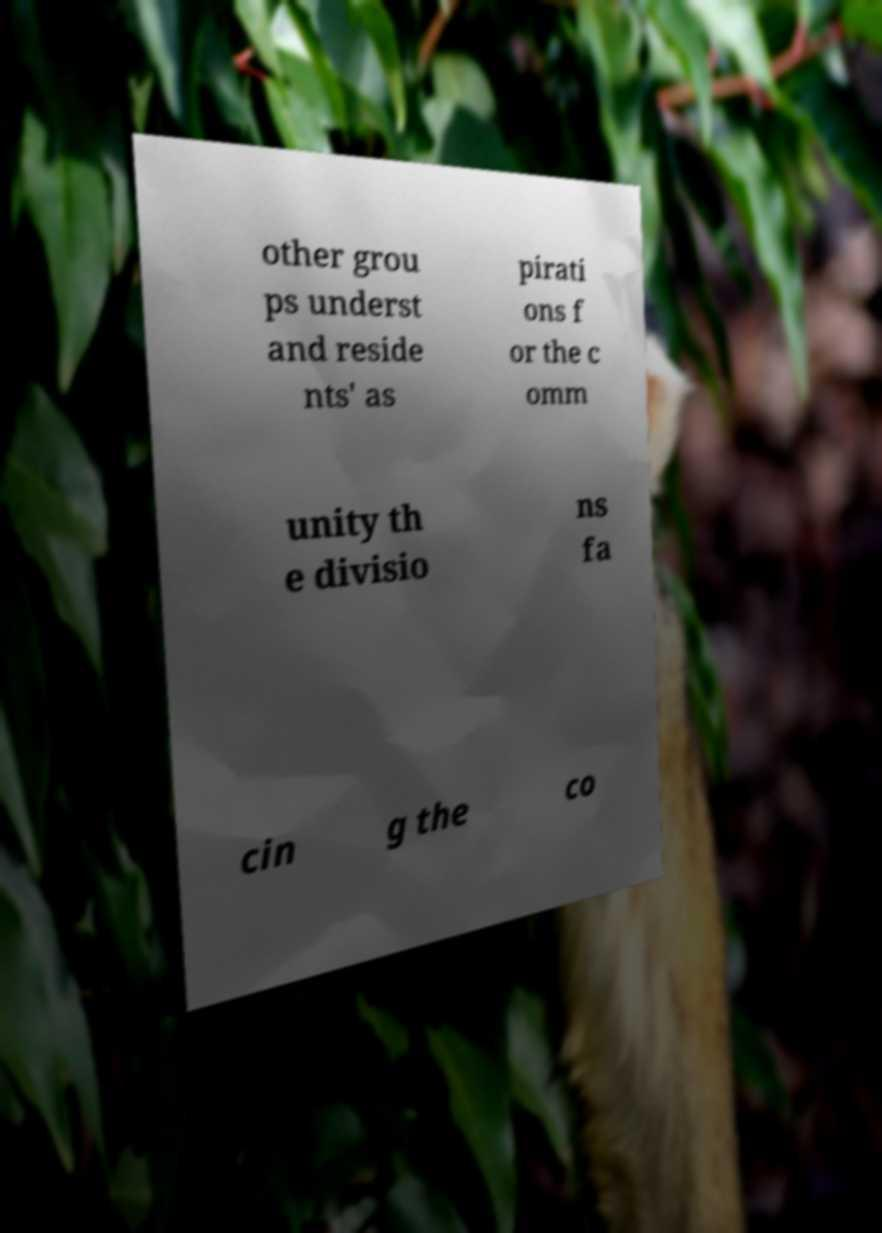What messages or text are displayed in this image? I need them in a readable, typed format. other grou ps underst and reside nts' as pirati ons f or the c omm unity th e divisio ns fa cin g the co 